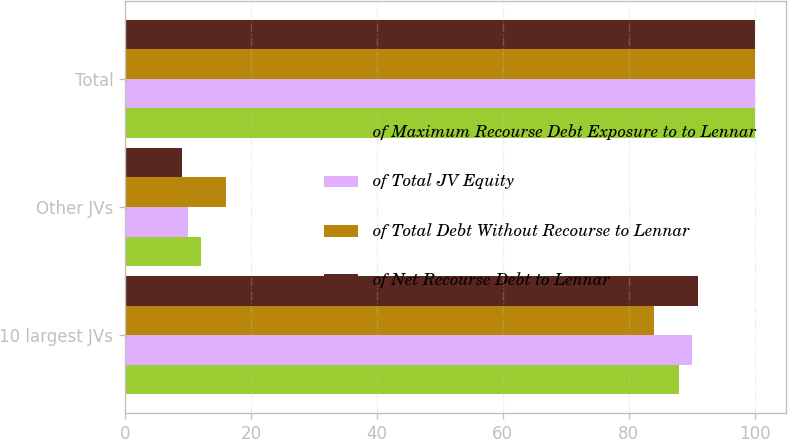Convert chart. <chart><loc_0><loc_0><loc_500><loc_500><stacked_bar_chart><ecel><fcel>10 largest JVs<fcel>Other JVs<fcel>Total<nl><fcel>of Maximum Recourse Debt Exposure to to Lennar<fcel>88<fcel>12<fcel>100<nl><fcel>of Total JV Equity<fcel>90<fcel>10<fcel>100<nl><fcel>of Total Debt Without Recourse to Lennar<fcel>84<fcel>16<fcel>100<nl><fcel>of Net Recourse Debt to Lennar<fcel>91<fcel>9<fcel>100<nl></chart> 